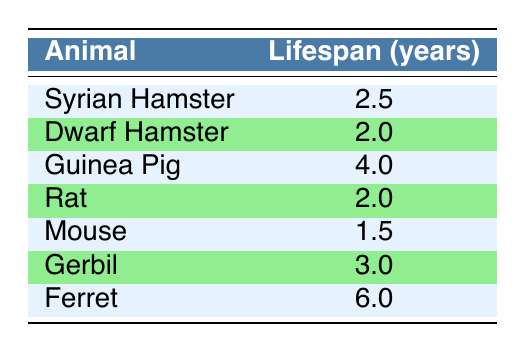What's the lifespan of a Guinea Pig? The table lists Guinea Pig under the "Animal" column and the corresponding lifespan value is found in the "Lifespan (years)" column, which is 4.0 years.
Answer: 4.0 years Which small animal pet has the longest lifespan? The table shows each animal with its lifespan, and the Ferret, with a lifespan of 6.0 years, is the highest among all listed pets.
Answer: Ferret What is the average lifespan of Dwarf Hamster and Rat? The lifespan of Dwarf Hamster is 2.0 years, and the lifespan of Rat is also 2.0 years. To find the average, we sum these values (2.0 + 2.0 = 4.0) and divide by the number of pets (2), which gives us an average of 4.0 years / 2 = 2.0 years.
Answer: 2.0 years Are there any pets with a lifespan longer than 3 years? We look at the "Lifespan (years)" column in the table. The Guinea Pig (4.0 years) and Ferret (6.0 years) are both over 3 years, confirming that yes, there are pets with a lifespan longer than 3 years.
Answer: Yes What is the difference in lifespan between the longest and shortest living pets? From the table, the Ferret has the longest lifespan at 6.0 years, while the Mouse has the shortest at 1.5 years. The difference is calculated by subtracting the Mouse's lifespan from the Ferret's: 6.0 - 1.5 = 4.5 years.
Answer: 4.5 years How many pets have a lifespan of 2.0 years? Looking at the table, both Dwarf Hamster and Rat have a lifespan listed as 2.0 years. There are two instances where pets match this criteria.
Answer: 2 Is the lifespan of a Syrian Hamster greater than 3 years? The table shows the lifespan of a Syrian Hamster as 2.5 years, which is less than 3 years. Therefore, the answer is no.
Answer: No What is the median lifespan among all the small animal pets listed? To find the median, we first list the lifespans in numerical order: 1.5, 2.0, 2.0, 2.5, 3.0, 4.0, 6.0. The middle value in this ordered list is 2.5 years, as there are seven values (the median is the fourth value).
Answer: 2.5 years 